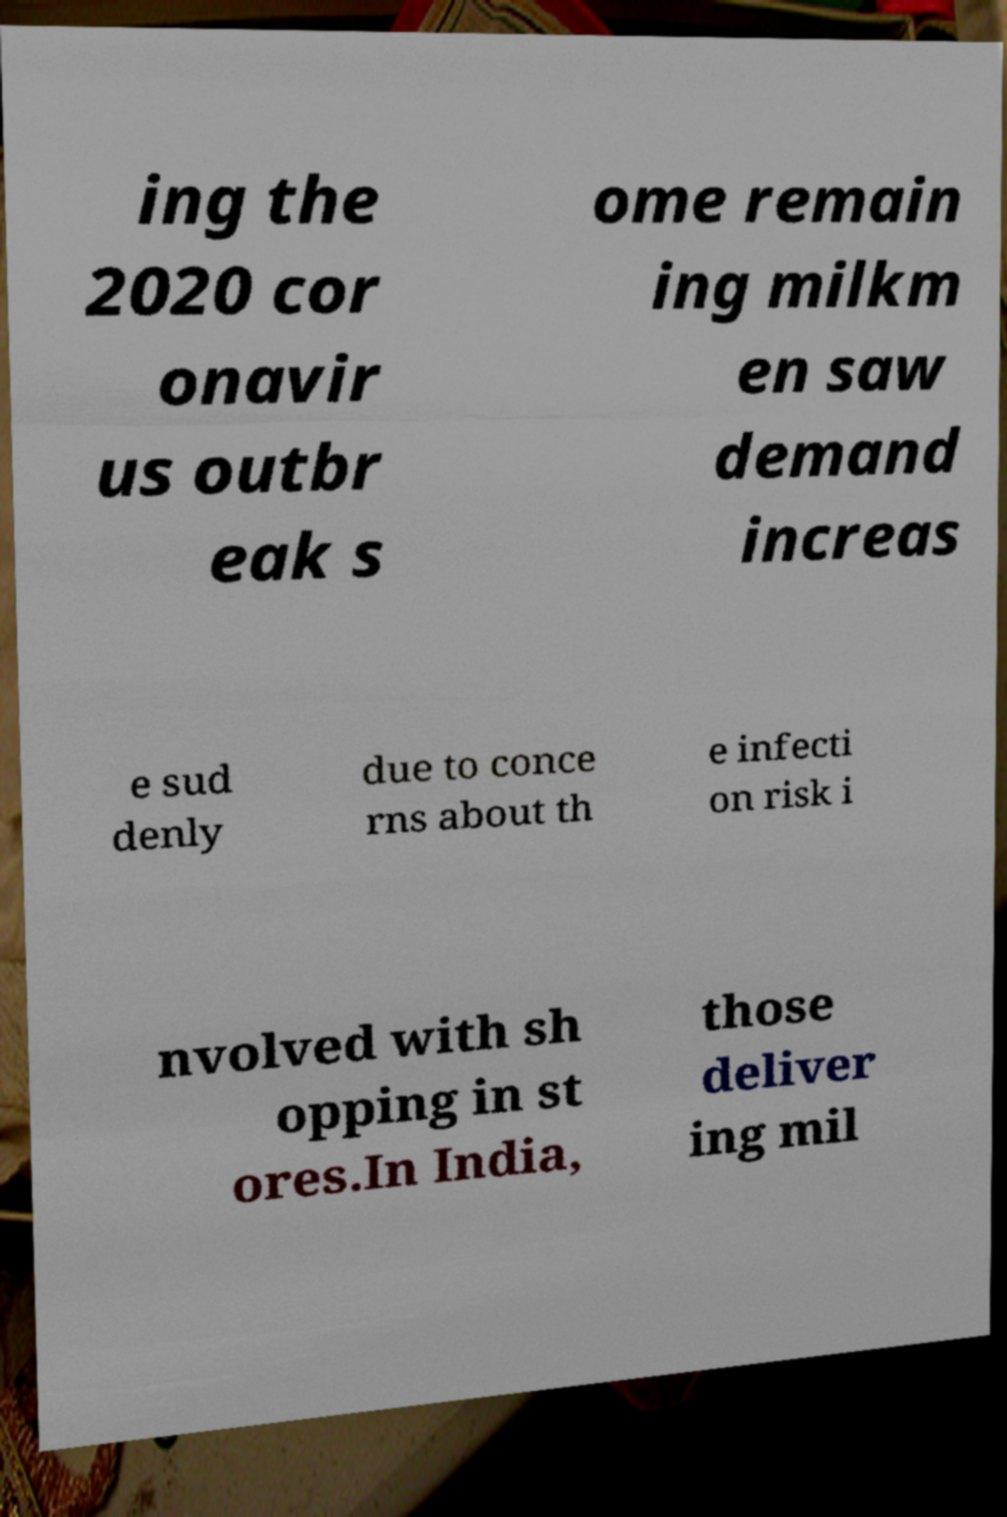Can you read and provide the text displayed in the image?This photo seems to have some interesting text. Can you extract and type it out for me? ing the 2020 cor onavir us outbr eak s ome remain ing milkm en saw demand increas e sud denly due to conce rns about th e infecti on risk i nvolved with sh opping in st ores.In India, those deliver ing mil 